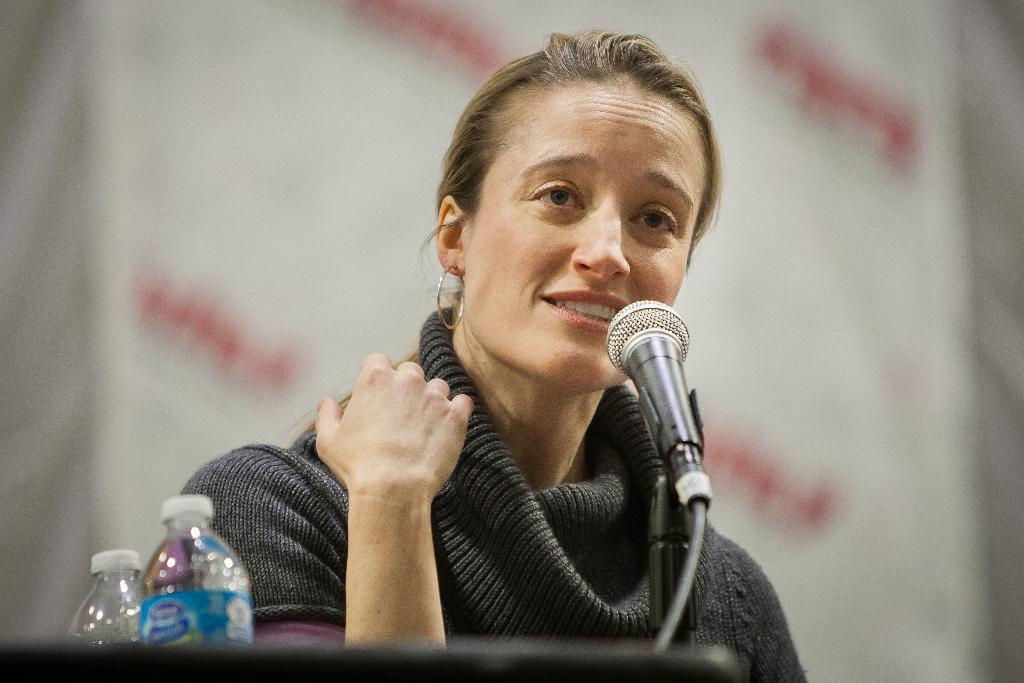Who is the main subject in the image? There is a woman in the image. What is the woman doing in the image? The woman is speaking in the image. What object is the woman using while speaking? The woman is in front of a microphone in the image. What else can be seen in the image besides the woman and the microphone? There are bottles visible in the image. What type of rabbit can be seen holding onto the microphone in the image? There is no rabbit present in the image, and the woman is the one holding onto the microphone. 